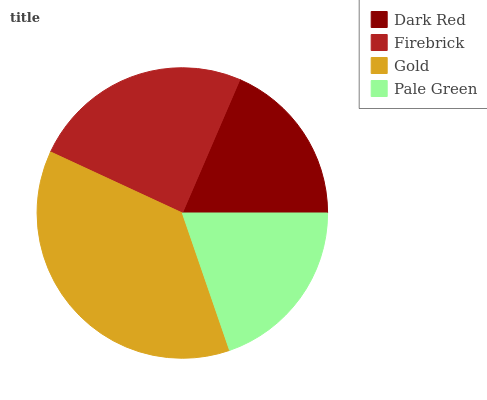Is Dark Red the minimum?
Answer yes or no. Yes. Is Gold the maximum?
Answer yes or no. Yes. Is Firebrick the minimum?
Answer yes or no. No. Is Firebrick the maximum?
Answer yes or no. No. Is Firebrick greater than Dark Red?
Answer yes or no. Yes. Is Dark Red less than Firebrick?
Answer yes or no. Yes. Is Dark Red greater than Firebrick?
Answer yes or no. No. Is Firebrick less than Dark Red?
Answer yes or no. No. Is Firebrick the high median?
Answer yes or no. Yes. Is Pale Green the low median?
Answer yes or no. Yes. Is Gold the high median?
Answer yes or no. No. Is Dark Red the low median?
Answer yes or no. No. 